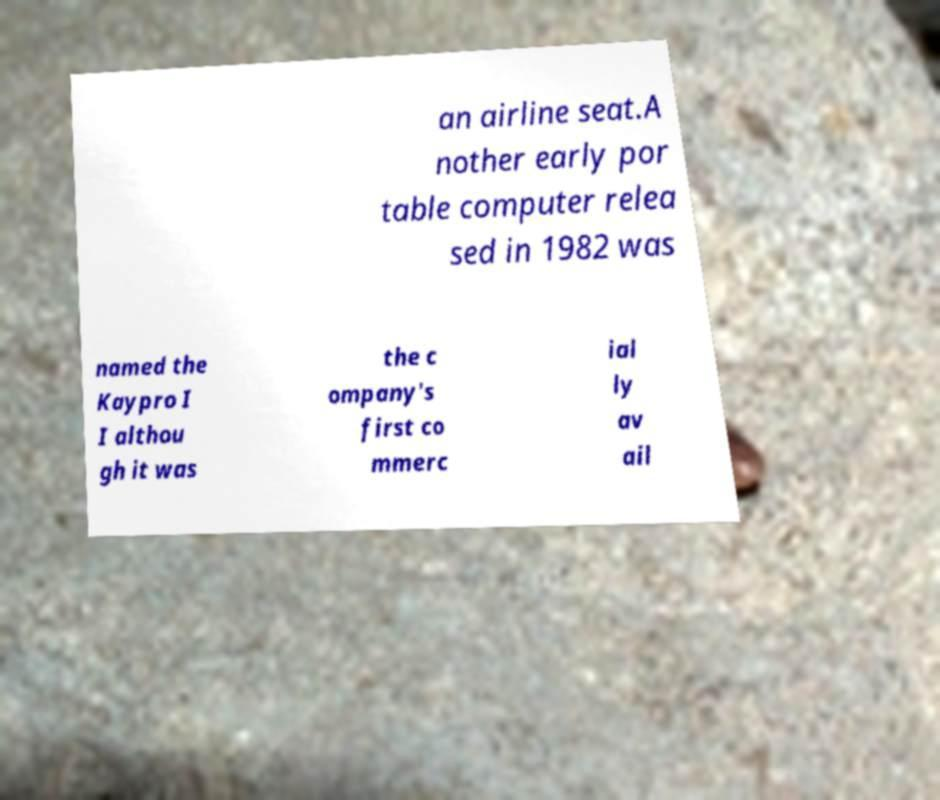What messages or text are displayed in this image? I need them in a readable, typed format. an airline seat.A nother early por table computer relea sed in 1982 was named the Kaypro I I althou gh it was the c ompany's first co mmerc ial ly av ail 